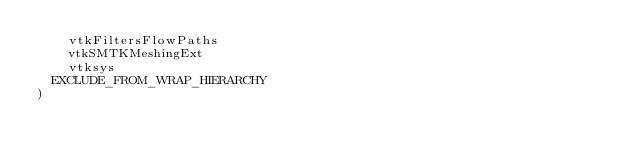Convert code to text. <code><loc_0><loc_0><loc_500><loc_500><_CMake_>    vtkFiltersFlowPaths
    vtkSMTKMeshingExt
    vtksys
  EXCLUDE_FROM_WRAP_HIERARCHY
)
</code> 